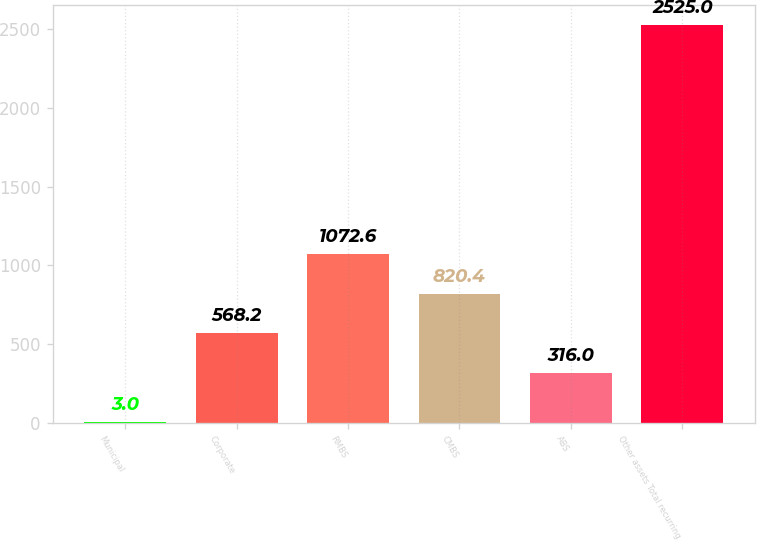Convert chart to OTSL. <chart><loc_0><loc_0><loc_500><loc_500><bar_chart><fcel>Municipal<fcel>Corporate<fcel>RMBS<fcel>CMBS<fcel>ABS<fcel>Other assets Total recurring<nl><fcel>3<fcel>568.2<fcel>1072.6<fcel>820.4<fcel>316<fcel>2525<nl></chart> 